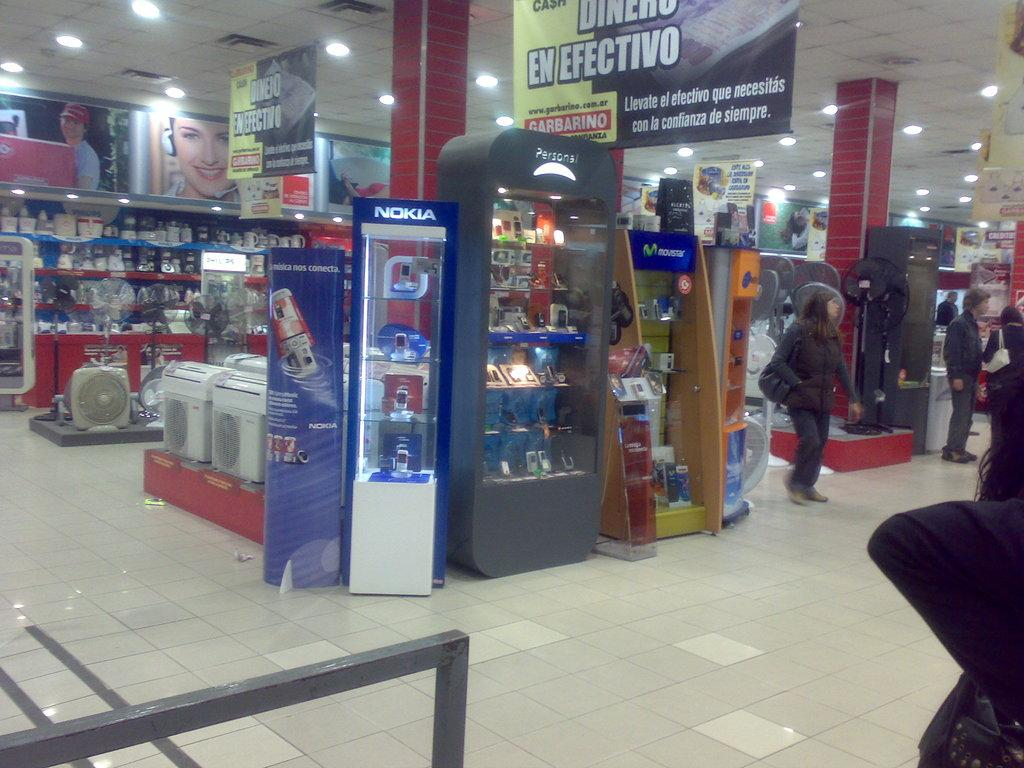<image>
Write a terse but informative summary of the picture. A department stores with a few people walking about and a sign above that reads, Garbarino. 